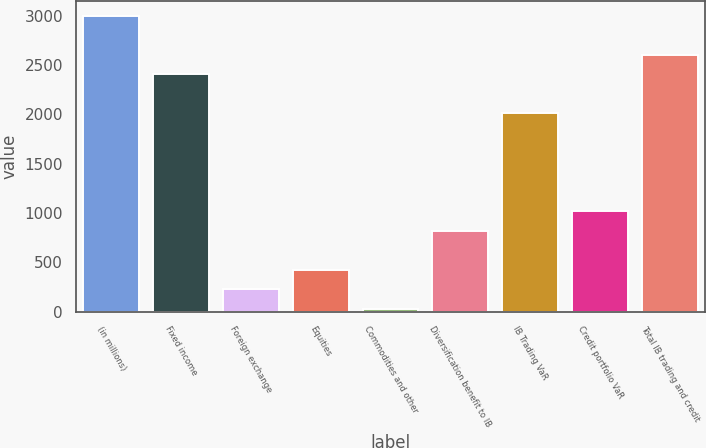Convert chart. <chart><loc_0><loc_0><loc_500><loc_500><bar_chart><fcel>(in millions)<fcel>Fixed income<fcel>Foreign exchange<fcel>Equities<fcel>Commodities and other<fcel>Diversification benefit to IB<fcel>IB Trading VaR<fcel>Credit portfolio VaR<fcel>Total IB trading and credit<nl><fcel>2999.5<fcel>2404.6<fcel>223.3<fcel>421.6<fcel>25<fcel>818.2<fcel>2008<fcel>1016.5<fcel>2602.9<nl></chart> 